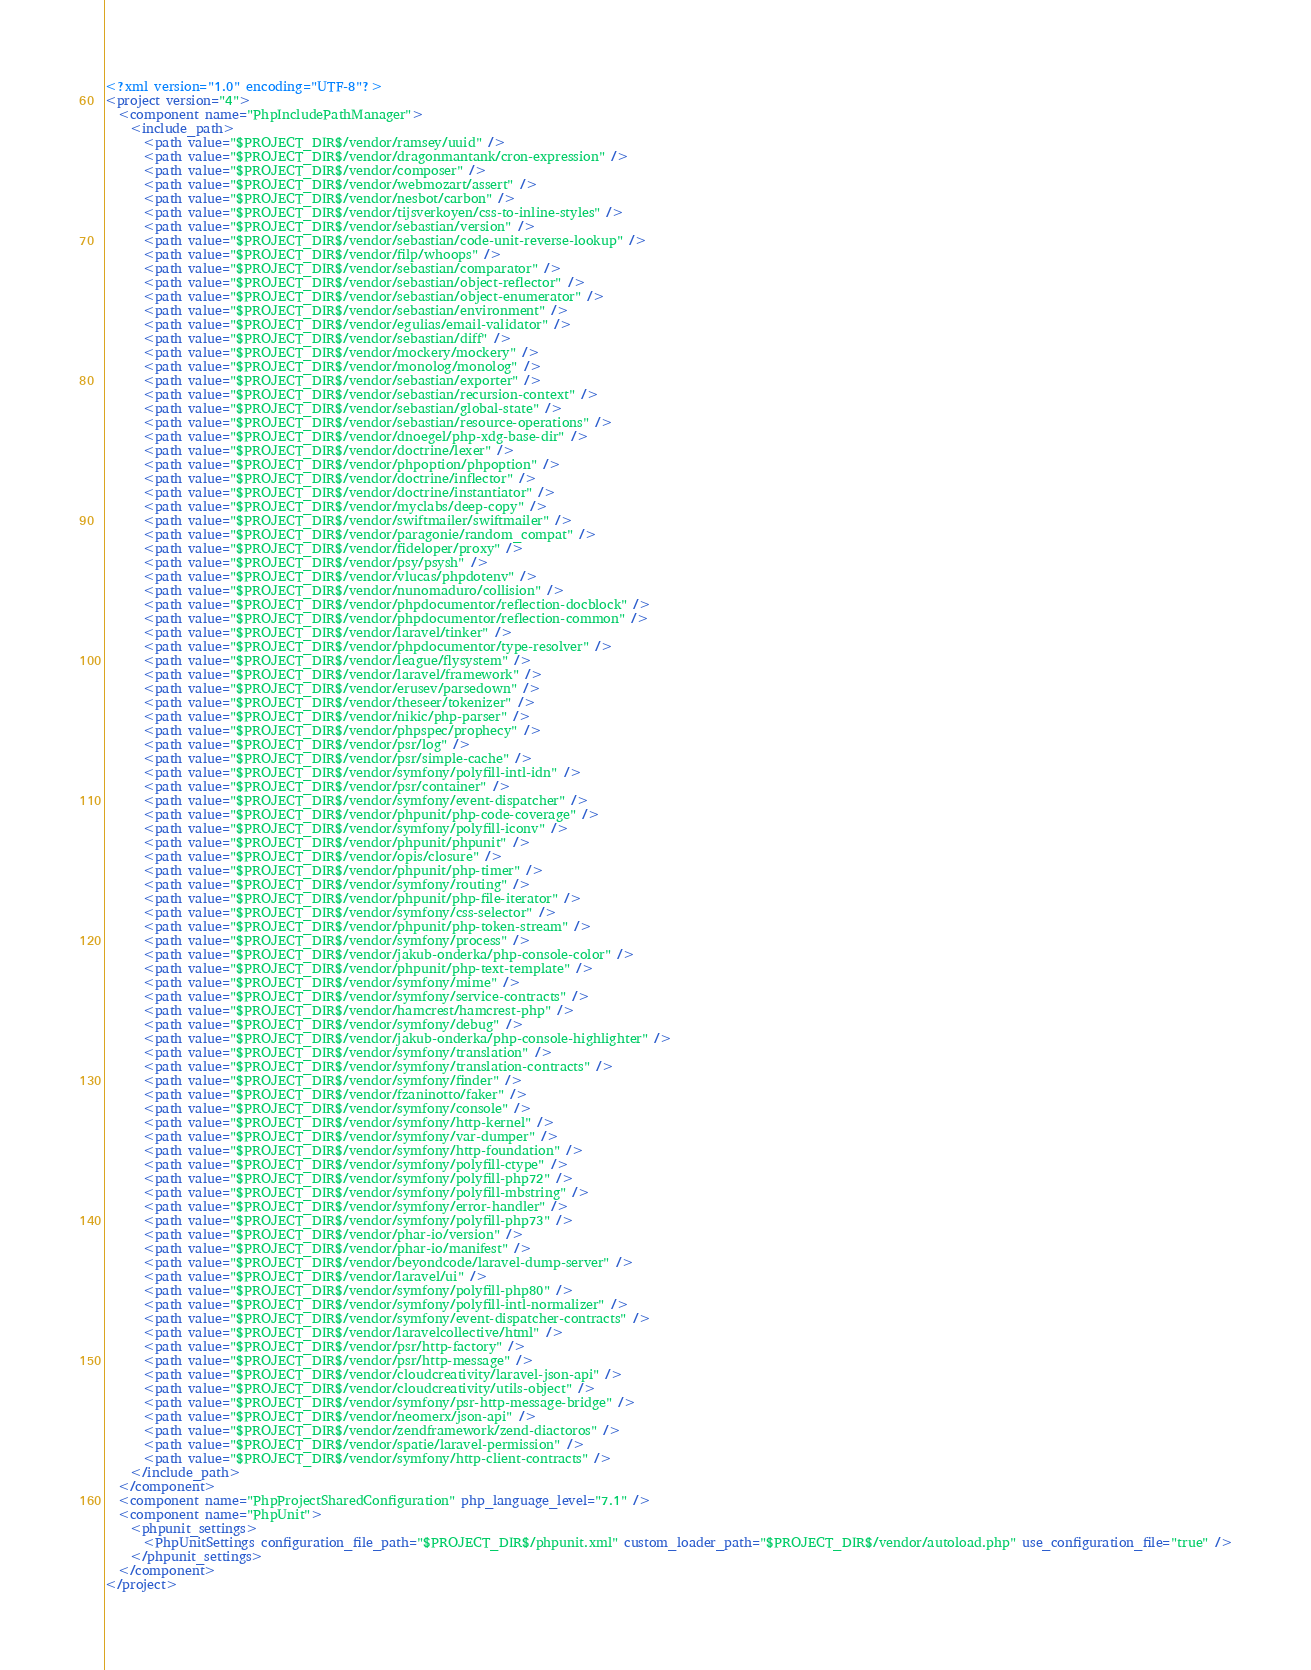Convert code to text. <code><loc_0><loc_0><loc_500><loc_500><_XML_><?xml version="1.0" encoding="UTF-8"?>
<project version="4">
  <component name="PhpIncludePathManager">
    <include_path>
      <path value="$PROJECT_DIR$/vendor/ramsey/uuid" />
      <path value="$PROJECT_DIR$/vendor/dragonmantank/cron-expression" />
      <path value="$PROJECT_DIR$/vendor/composer" />
      <path value="$PROJECT_DIR$/vendor/webmozart/assert" />
      <path value="$PROJECT_DIR$/vendor/nesbot/carbon" />
      <path value="$PROJECT_DIR$/vendor/tijsverkoyen/css-to-inline-styles" />
      <path value="$PROJECT_DIR$/vendor/sebastian/version" />
      <path value="$PROJECT_DIR$/vendor/sebastian/code-unit-reverse-lookup" />
      <path value="$PROJECT_DIR$/vendor/filp/whoops" />
      <path value="$PROJECT_DIR$/vendor/sebastian/comparator" />
      <path value="$PROJECT_DIR$/vendor/sebastian/object-reflector" />
      <path value="$PROJECT_DIR$/vendor/sebastian/object-enumerator" />
      <path value="$PROJECT_DIR$/vendor/sebastian/environment" />
      <path value="$PROJECT_DIR$/vendor/egulias/email-validator" />
      <path value="$PROJECT_DIR$/vendor/sebastian/diff" />
      <path value="$PROJECT_DIR$/vendor/mockery/mockery" />
      <path value="$PROJECT_DIR$/vendor/monolog/monolog" />
      <path value="$PROJECT_DIR$/vendor/sebastian/exporter" />
      <path value="$PROJECT_DIR$/vendor/sebastian/recursion-context" />
      <path value="$PROJECT_DIR$/vendor/sebastian/global-state" />
      <path value="$PROJECT_DIR$/vendor/sebastian/resource-operations" />
      <path value="$PROJECT_DIR$/vendor/dnoegel/php-xdg-base-dir" />
      <path value="$PROJECT_DIR$/vendor/doctrine/lexer" />
      <path value="$PROJECT_DIR$/vendor/phpoption/phpoption" />
      <path value="$PROJECT_DIR$/vendor/doctrine/inflector" />
      <path value="$PROJECT_DIR$/vendor/doctrine/instantiator" />
      <path value="$PROJECT_DIR$/vendor/myclabs/deep-copy" />
      <path value="$PROJECT_DIR$/vendor/swiftmailer/swiftmailer" />
      <path value="$PROJECT_DIR$/vendor/paragonie/random_compat" />
      <path value="$PROJECT_DIR$/vendor/fideloper/proxy" />
      <path value="$PROJECT_DIR$/vendor/psy/psysh" />
      <path value="$PROJECT_DIR$/vendor/vlucas/phpdotenv" />
      <path value="$PROJECT_DIR$/vendor/nunomaduro/collision" />
      <path value="$PROJECT_DIR$/vendor/phpdocumentor/reflection-docblock" />
      <path value="$PROJECT_DIR$/vendor/phpdocumentor/reflection-common" />
      <path value="$PROJECT_DIR$/vendor/laravel/tinker" />
      <path value="$PROJECT_DIR$/vendor/phpdocumentor/type-resolver" />
      <path value="$PROJECT_DIR$/vendor/league/flysystem" />
      <path value="$PROJECT_DIR$/vendor/laravel/framework" />
      <path value="$PROJECT_DIR$/vendor/erusev/parsedown" />
      <path value="$PROJECT_DIR$/vendor/theseer/tokenizer" />
      <path value="$PROJECT_DIR$/vendor/nikic/php-parser" />
      <path value="$PROJECT_DIR$/vendor/phpspec/prophecy" />
      <path value="$PROJECT_DIR$/vendor/psr/log" />
      <path value="$PROJECT_DIR$/vendor/psr/simple-cache" />
      <path value="$PROJECT_DIR$/vendor/symfony/polyfill-intl-idn" />
      <path value="$PROJECT_DIR$/vendor/psr/container" />
      <path value="$PROJECT_DIR$/vendor/symfony/event-dispatcher" />
      <path value="$PROJECT_DIR$/vendor/phpunit/php-code-coverage" />
      <path value="$PROJECT_DIR$/vendor/symfony/polyfill-iconv" />
      <path value="$PROJECT_DIR$/vendor/phpunit/phpunit" />
      <path value="$PROJECT_DIR$/vendor/opis/closure" />
      <path value="$PROJECT_DIR$/vendor/phpunit/php-timer" />
      <path value="$PROJECT_DIR$/vendor/symfony/routing" />
      <path value="$PROJECT_DIR$/vendor/phpunit/php-file-iterator" />
      <path value="$PROJECT_DIR$/vendor/symfony/css-selector" />
      <path value="$PROJECT_DIR$/vendor/phpunit/php-token-stream" />
      <path value="$PROJECT_DIR$/vendor/symfony/process" />
      <path value="$PROJECT_DIR$/vendor/jakub-onderka/php-console-color" />
      <path value="$PROJECT_DIR$/vendor/phpunit/php-text-template" />
      <path value="$PROJECT_DIR$/vendor/symfony/mime" />
      <path value="$PROJECT_DIR$/vendor/symfony/service-contracts" />
      <path value="$PROJECT_DIR$/vendor/hamcrest/hamcrest-php" />
      <path value="$PROJECT_DIR$/vendor/symfony/debug" />
      <path value="$PROJECT_DIR$/vendor/jakub-onderka/php-console-highlighter" />
      <path value="$PROJECT_DIR$/vendor/symfony/translation" />
      <path value="$PROJECT_DIR$/vendor/symfony/translation-contracts" />
      <path value="$PROJECT_DIR$/vendor/symfony/finder" />
      <path value="$PROJECT_DIR$/vendor/fzaninotto/faker" />
      <path value="$PROJECT_DIR$/vendor/symfony/console" />
      <path value="$PROJECT_DIR$/vendor/symfony/http-kernel" />
      <path value="$PROJECT_DIR$/vendor/symfony/var-dumper" />
      <path value="$PROJECT_DIR$/vendor/symfony/http-foundation" />
      <path value="$PROJECT_DIR$/vendor/symfony/polyfill-ctype" />
      <path value="$PROJECT_DIR$/vendor/symfony/polyfill-php72" />
      <path value="$PROJECT_DIR$/vendor/symfony/polyfill-mbstring" />
      <path value="$PROJECT_DIR$/vendor/symfony/error-handler" />
      <path value="$PROJECT_DIR$/vendor/symfony/polyfill-php73" />
      <path value="$PROJECT_DIR$/vendor/phar-io/version" />
      <path value="$PROJECT_DIR$/vendor/phar-io/manifest" />
      <path value="$PROJECT_DIR$/vendor/beyondcode/laravel-dump-server" />
      <path value="$PROJECT_DIR$/vendor/laravel/ui" />
      <path value="$PROJECT_DIR$/vendor/symfony/polyfill-php80" />
      <path value="$PROJECT_DIR$/vendor/symfony/polyfill-intl-normalizer" />
      <path value="$PROJECT_DIR$/vendor/symfony/event-dispatcher-contracts" />
      <path value="$PROJECT_DIR$/vendor/laravelcollective/html" />
      <path value="$PROJECT_DIR$/vendor/psr/http-factory" />
      <path value="$PROJECT_DIR$/vendor/psr/http-message" />
      <path value="$PROJECT_DIR$/vendor/cloudcreativity/laravel-json-api" />
      <path value="$PROJECT_DIR$/vendor/cloudcreativity/utils-object" />
      <path value="$PROJECT_DIR$/vendor/symfony/psr-http-message-bridge" />
      <path value="$PROJECT_DIR$/vendor/neomerx/json-api" />
      <path value="$PROJECT_DIR$/vendor/zendframework/zend-diactoros" />
      <path value="$PROJECT_DIR$/vendor/spatie/laravel-permission" />
      <path value="$PROJECT_DIR$/vendor/symfony/http-client-contracts" />
    </include_path>
  </component>
  <component name="PhpProjectSharedConfiguration" php_language_level="7.1" />
  <component name="PhpUnit">
    <phpunit_settings>
      <PhpUnitSettings configuration_file_path="$PROJECT_DIR$/phpunit.xml" custom_loader_path="$PROJECT_DIR$/vendor/autoload.php" use_configuration_file="true" />
    </phpunit_settings>
  </component>
</project></code> 